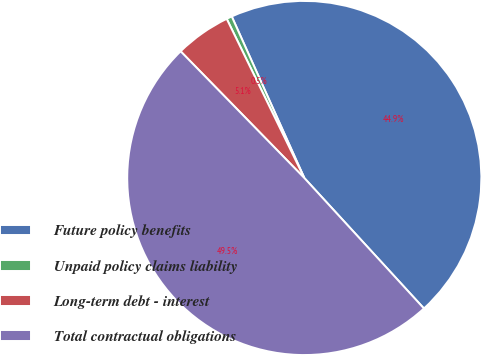Convert chart. <chart><loc_0><loc_0><loc_500><loc_500><pie_chart><fcel>Future policy benefits<fcel>Unpaid policy claims liability<fcel>Long-term debt - interest<fcel>Total contractual obligations<nl><fcel>44.91%<fcel>0.5%<fcel>5.09%<fcel>49.5%<nl></chart> 